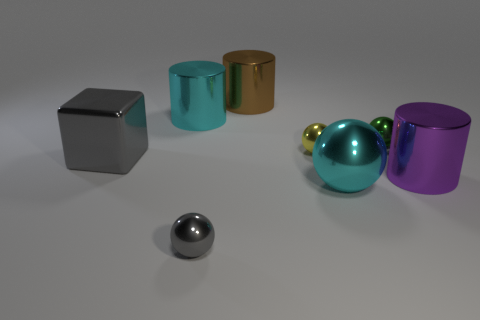Subtract all tiny spheres. How many spheres are left? 1 Subtract 1 cylinders. How many cylinders are left? 2 Subtract all gray spheres. How many spheres are left? 3 Add 1 gray cylinders. How many objects exist? 9 Subtract all red cylinders. Subtract all blue balls. How many cylinders are left? 3 Subtract 1 gray balls. How many objects are left? 7 Subtract all cubes. How many objects are left? 7 Subtract all brown shiny objects. Subtract all large purple shiny objects. How many objects are left? 6 Add 8 yellow balls. How many yellow balls are left? 9 Add 6 large gray objects. How many large gray objects exist? 7 